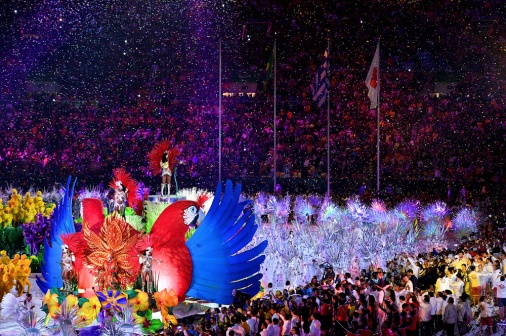What cultural significance might this parade hold? While it's impossible to determine the exact cultural significance without more context, the grandeur and thematic elements of the parade suggest it could be a celebration of cultural identity, heritage, or a significant historical event. The intricate costumes, vibrant colors, and symbolically rich floats typically represent local traditions, mythology, or national pride. Such events often aim to strengthen communal bonds, showcase artistic expression, and honor storied pasts. They can be vital for maintaining cultural narratives and providing a shared experience for both participants and spectators, fostering a sense of unity and continuity with ancestral roots. 